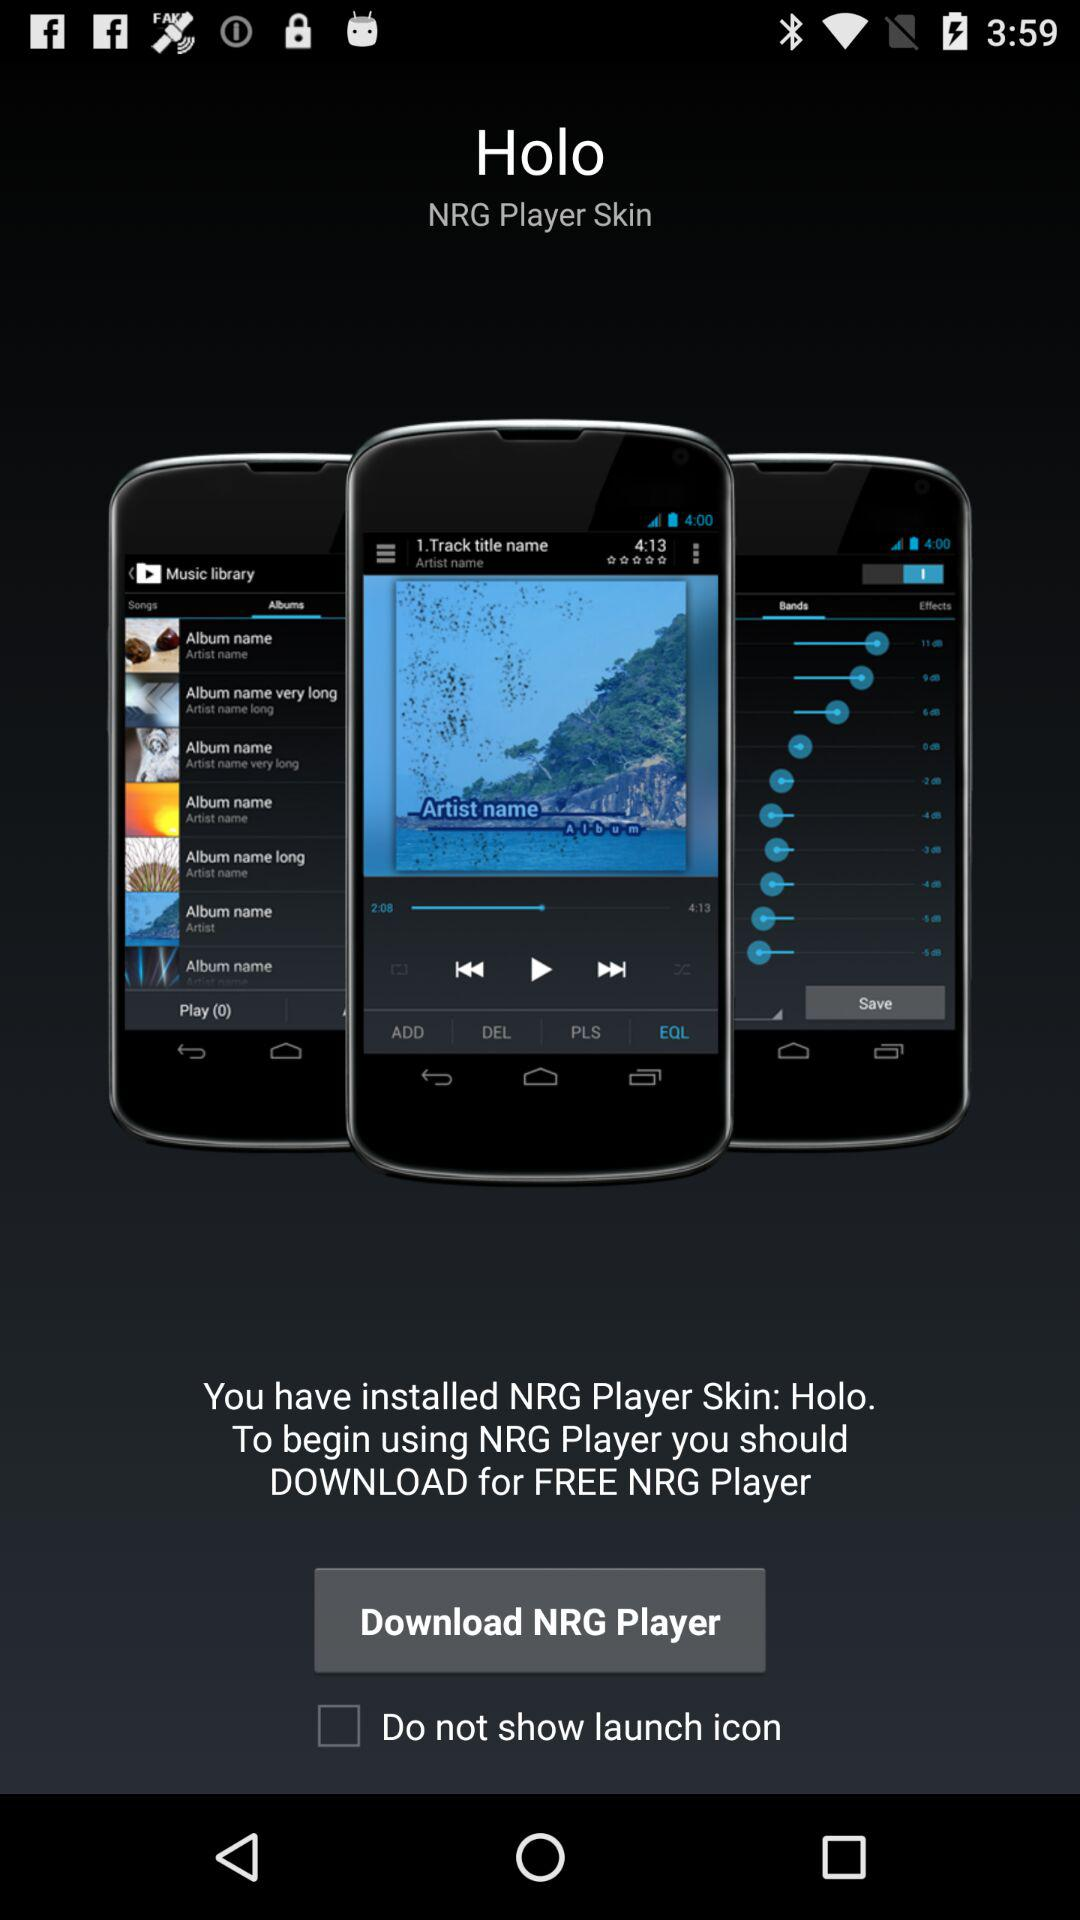What is the status of "Do not show launch icon"? The status of "Do not show launch icon" is "off". 